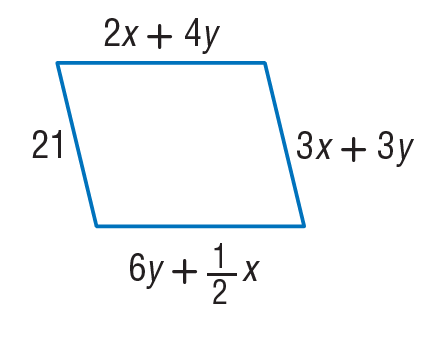Answer the mathemtical geometry problem and directly provide the correct option letter.
Question: Find x so that the quadrilateral is a parallelogram.
Choices: A: 4 B: 6 C: 8 D: 12 A 